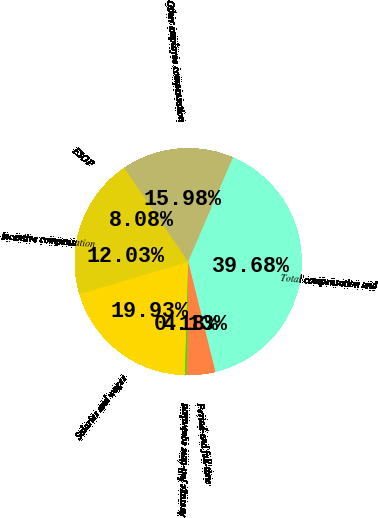Convert chart. <chart><loc_0><loc_0><loc_500><loc_500><pie_chart><fcel>Salaries and wages<fcel>Incentive compensation<fcel>ESOP<fcel>Other employee compensation<fcel>Total compensation and<fcel>Period-end full-time<fcel>Average full-time equivalent<nl><fcel>19.93%<fcel>12.03%<fcel>8.08%<fcel>15.98%<fcel>39.68%<fcel>4.13%<fcel>0.18%<nl></chart> 